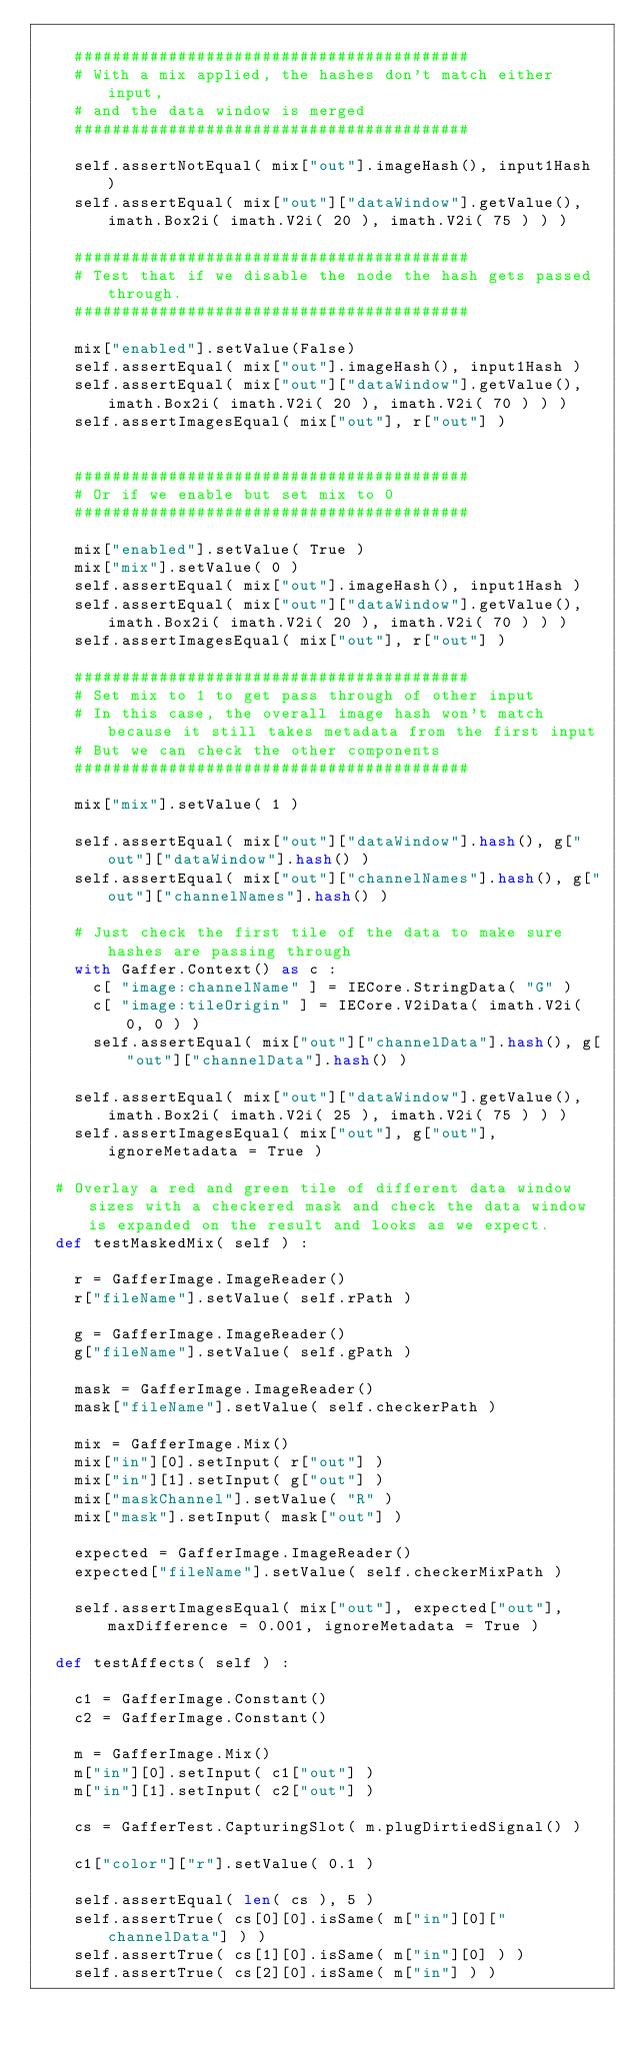Convert code to text. <code><loc_0><loc_0><loc_500><loc_500><_Python_>
		##########################################
		# With a mix applied, the hashes don't match either input,
		# and the data window is merged
		##########################################

		self.assertNotEqual( mix["out"].imageHash(), input1Hash )
		self.assertEqual( mix["out"]["dataWindow"].getValue(), imath.Box2i( imath.V2i( 20 ), imath.V2i( 75 ) ) )

		##########################################
		# Test that if we disable the node the hash gets passed through.
		##########################################

		mix["enabled"].setValue(False)
		self.assertEqual( mix["out"].imageHash(), input1Hash )
		self.assertEqual( mix["out"]["dataWindow"].getValue(), imath.Box2i( imath.V2i( 20 ), imath.V2i( 70 ) ) )
		self.assertImagesEqual( mix["out"], r["out"] )


		##########################################
		# Or if we enable but set mix to 0
		##########################################

		mix["enabled"].setValue( True )
		mix["mix"].setValue( 0 )
		self.assertEqual( mix["out"].imageHash(), input1Hash )
		self.assertEqual( mix["out"]["dataWindow"].getValue(), imath.Box2i( imath.V2i( 20 ), imath.V2i( 70 ) ) )
		self.assertImagesEqual( mix["out"], r["out"] )

		##########################################
		# Set mix to 1 to get pass through of other input
		# In this case, the overall image hash won't match because it still takes metadata from the first input
		# But we can check the other components
		##########################################

		mix["mix"].setValue( 1 )

		self.assertEqual( mix["out"]["dataWindow"].hash(), g["out"]["dataWindow"].hash() )
		self.assertEqual( mix["out"]["channelNames"].hash(), g["out"]["channelNames"].hash() )

		# Just check the first tile of the data to make sure hashes are passing through
		with Gaffer.Context() as c :
			c[ "image:channelName" ] = IECore.StringData( "G" )
			c[ "image:tileOrigin" ] = IECore.V2iData( imath.V2i( 0, 0 ) )
			self.assertEqual( mix["out"]["channelData"].hash(), g["out"]["channelData"].hash() )

		self.assertEqual( mix["out"]["dataWindow"].getValue(), imath.Box2i( imath.V2i( 25 ), imath.V2i( 75 ) ) )
		self.assertImagesEqual( mix["out"], g["out"], ignoreMetadata = True )

	# Overlay a red and green tile of different data window sizes with a checkered mask and check the data window is expanded on the result and looks as we expect.
	def testMaskedMix( self ) :

		r = GafferImage.ImageReader()
		r["fileName"].setValue( self.rPath )

		g = GafferImage.ImageReader()
		g["fileName"].setValue( self.gPath )

		mask = GafferImage.ImageReader()
		mask["fileName"].setValue( self.checkerPath )

		mix = GafferImage.Mix()
		mix["in"][0].setInput( r["out"] )
		mix["in"][1].setInput( g["out"] )
		mix["maskChannel"].setValue( "R" )
		mix["mask"].setInput( mask["out"] )

		expected = GafferImage.ImageReader()
		expected["fileName"].setValue( self.checkerMixPath )

		self.assertImagesEqual( mix["out"], expected["out"], maxDifference = 0.001, ignoreMetadata = True )

	def testAffects( self ) :

		c1 = GafferImage.Constant()
		c2 = GafferImage.Constant()

		m = GafferImage.Mix()
		m["in"][0].setInput( c1["out"] )
		m["in"][1].setInput( c2["out"] )

		cs = GafferTest.CapturingSlot( m.plugDirtiedSignal() )

		c1["color"]["r"].setValue( 0.1 )

		self.assertEqual( len( cs ), 5 )
		self.assertTrue( cs[0][0].isSame( m["in"][0]["channelData"] ) )
		self.assertTrue( cs[1][0].isSame( m["in"][0] ) )
		self.assertTrue( cs[2][0].isSame( m["in"] ) )</code> 